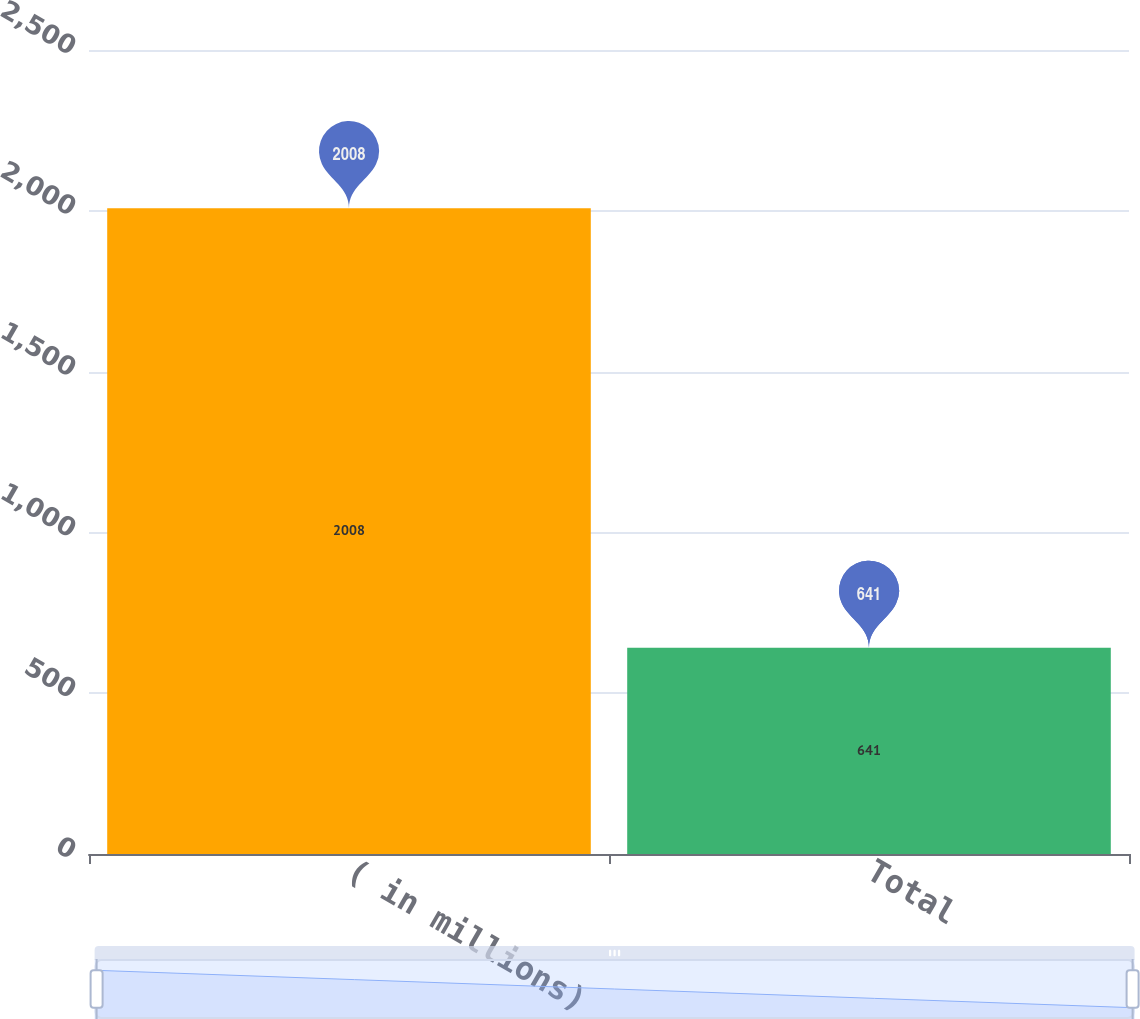Convert chart to OTSL. <chart><loc_0><loc_0><loc_500><loc_500><bar_chart><fcel>( in millions)<fcel>Total<nl><fcel>2008<fcel>641<nl></chart> 